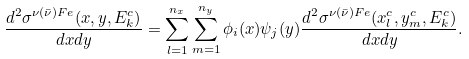<formula> <loc_0><loc_0><loc_500><loc_500>\frac { d ^ { 2 } \sigma ^ { \nu ( \bar { \nu } ) F e } ( x , y , E _ { k } ^ { c } ) } { d x d y } = \sum _ { l = 1 } ^ { n _ { x } } \sum _ { m = 1 } ^ { n _ { y } } \phi _ { i } ( x ) \psi _ { j } ( y ) \frac { d ^ { 2 } \sigma ^ { \nu ( \bar { \nu } ) F e } ( x _ { l } ^ { c } , y _ { m } ^ { c } , E _ { k } ^ { c } ) } { d x d y } .</formula> 